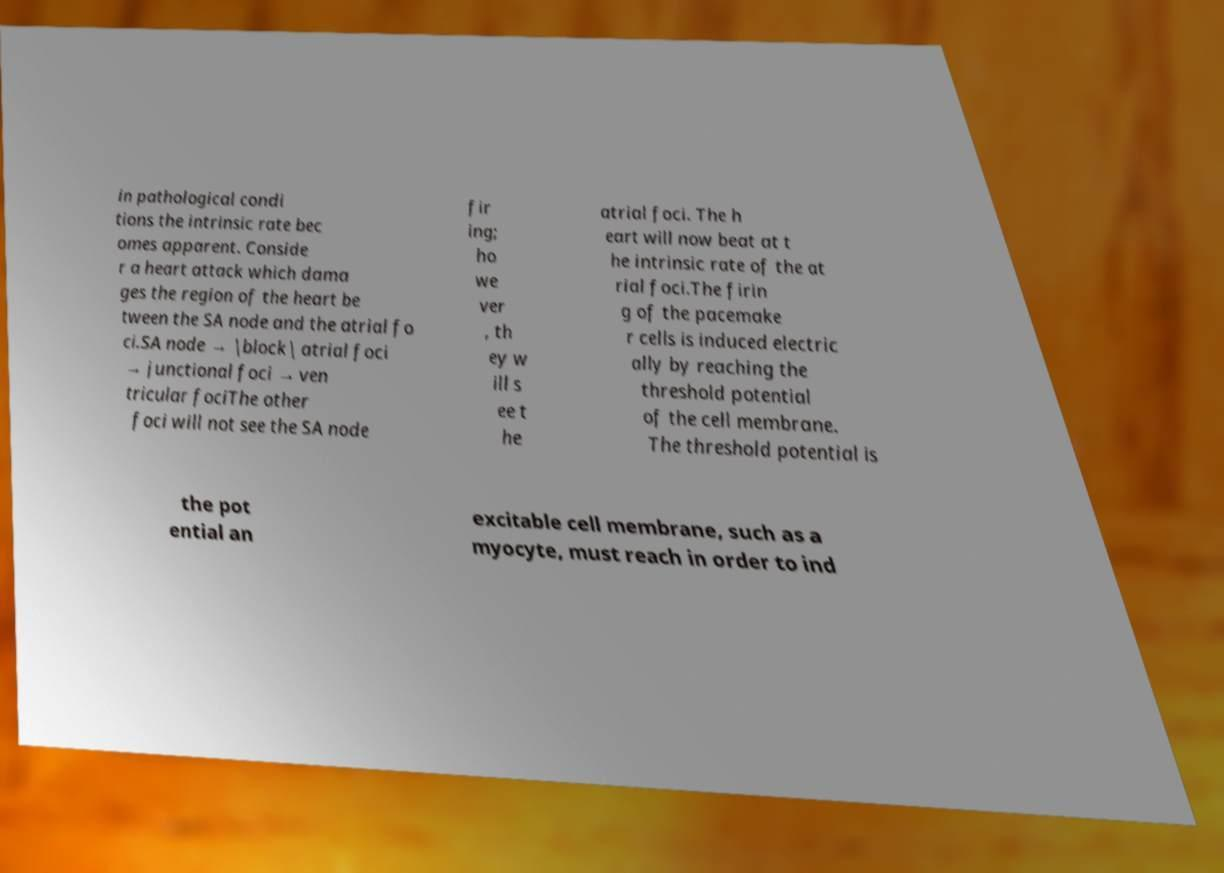There's text embedded in this image that I need extracted. Can you transcribe it verbatim? in pathological condi tions the intrinsic rate bec omes apparent. Conside r a heart attack which dama ges the region of the heart be tween the SA node and the atrial fo ci.SA node → |block| atrial foci → junctional foci → ven tricular fociThe other foci will not see the SA node fir ing; ho we ver , th ey w ill s ee t he atrial foci. The h eart will now beat at t he intrinsic rate of the at rial foci.The firin g of the pacemake r cells is induced electric ally by reaching the threshold potential of the cell membrane. The threshold potential is the pot ential an excitable cell membrane, such as a myocyte, must reach in order to ind 